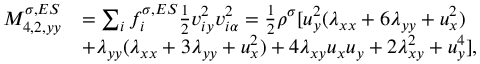Convert formula to latex. <formula><loc_0><loc_0><loc_500><loc_500>\begin{array} { r } { \begin{array} { r l } { M _ { 4 , 2 , y y } ^ { \sigma , E S } } & { = \sum _ { i } f _ { i } ^ { \sigma , E S } \frac { 1 } { 2 } v _ { i y } ^ { 2 } v _ { i \alpha } ^ { 2 } = \frac { 1 } { 2 } \rho ^ { \sigma } [ u _ { y } ^ { 2 } ( \lambda _ { x x } + 6 \lambda _ { y y } + u _ { x } ^ { 2 } ) } \\ & { + \lambda _ { y y } ( \lambda _ { x x } + 3 \lambda _ { y y } + u _ { x } ^ { 2 } ) + 4 \lambda _ { x y } u _ { x } u _ { y } + 2 \lambda _ { x y } ^ { 2 } + u _ { y } ^ { 4 } ] , } \end{array} } \end{array}</formula> 